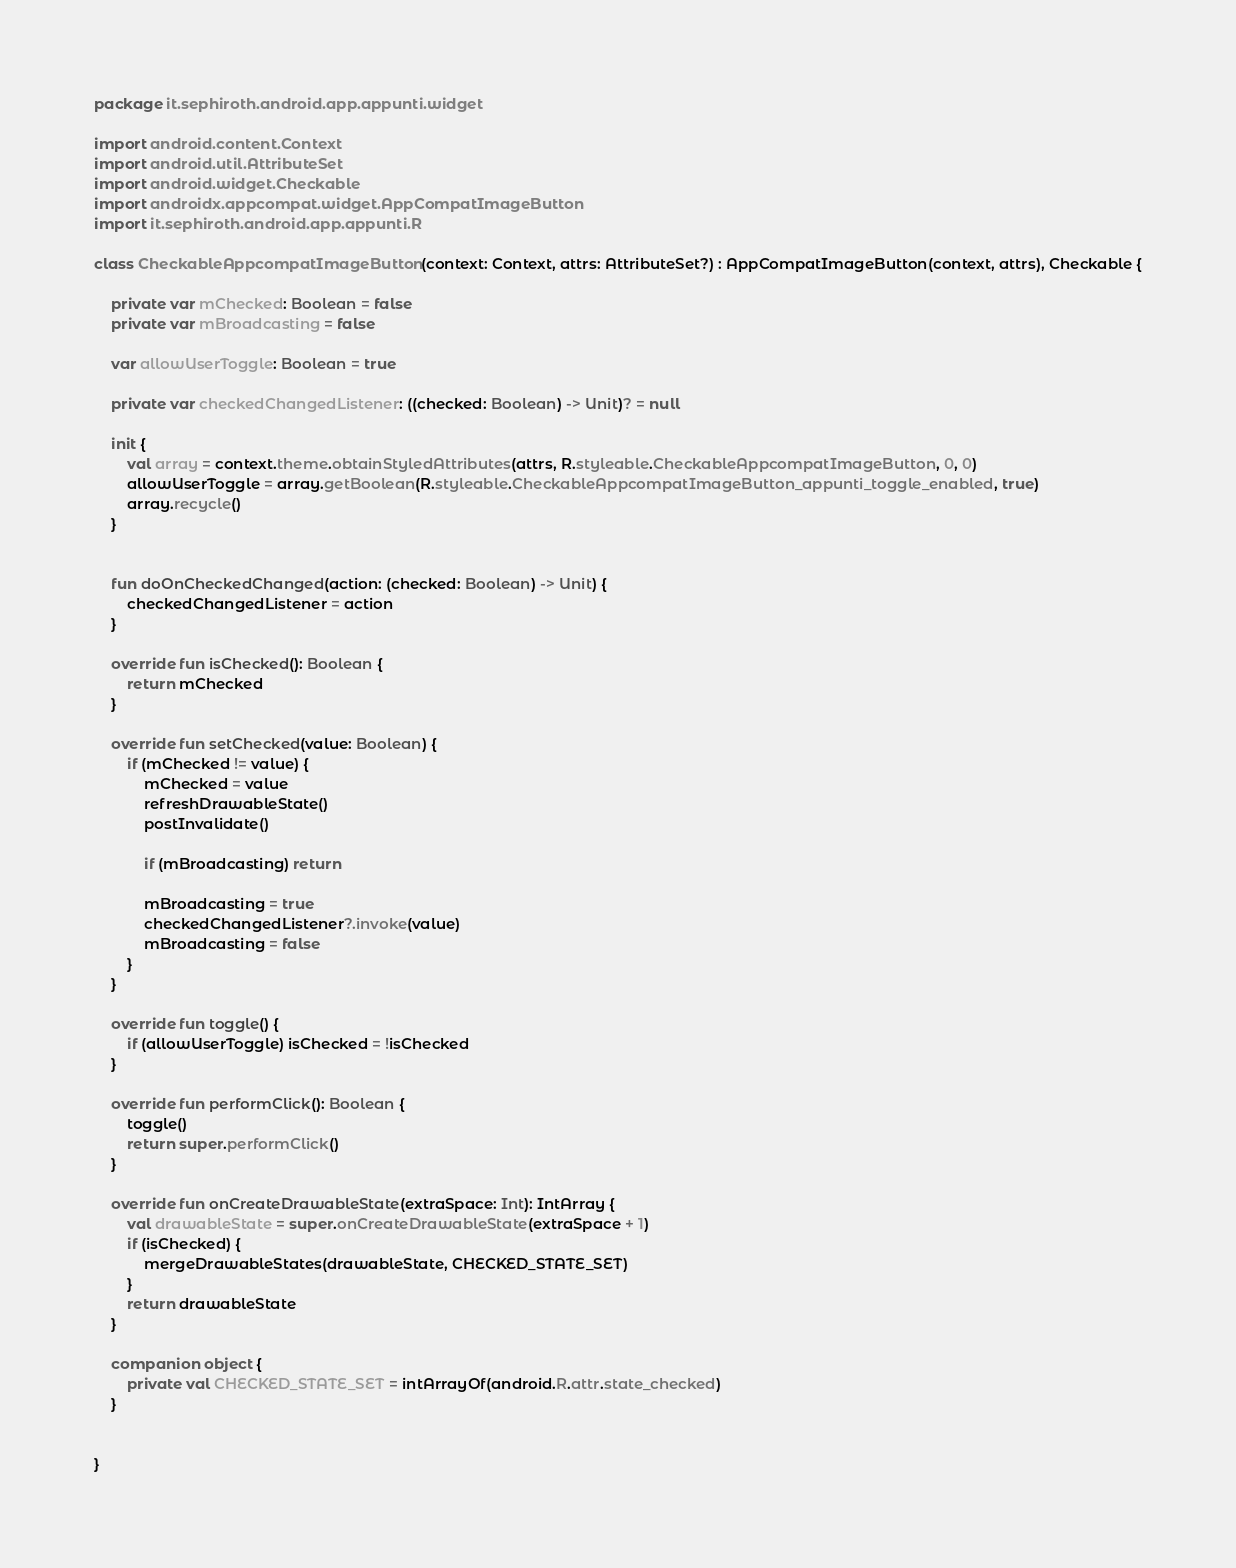<code> <loc_0><loc_0><loc_500><loc_500><_Kotlin_>package it.sephiroth.android.app.appunti.widget

import android.content.Context
import android.util.AttributeSet
import android.widget.Checkable
import androidx.appcompat.widget.AppCompatImageButton
import it.sephiroth.android.app.appunti.R

class CheckableAppcompatImageButton(context: Context, attrs: AttributeSet?) : AppCompatImageButton(context, attrs), Checkable {

    private var mChecked: Boolean = false
    private var mBroadcasting = false

    var allowUserToggle: Boolean = true

    private var checkedChangedListener: ((checked: Boolean) -> Unit)? = null

    init {
        val array = context.theme.obtainStyledAttributes(attrs, R.styleable.CheckableAppcompatImageButton, 0, 0)
        allowUserToggle = array.getBoolean(R.styleable.CheckableAppcompatImageButton_appunti_toggle_enabled, true)
        array.recycle()
    }


    fun doOnCheckedChanged(action: (checked: Boolean) -> Unit) {
        checkedChangedListener = action
    }

    override fun isChecked(): Boolean {
        return mChecked
    }

    override fun setChecked(value: Boolean) {
        if (mChecked != value) {
            mChecked = value
            refreshDrawableState()
            postInvalidate()

            if (mBroadcasting) return

            mBroadcasting = true
            checkedChangedListener?.invoke(value)
            mBroadcasting = false
        }
    }

    override fun toggle() {
        if (allowUserToggle) isChecked = !isChecked
    }

    override fun performClick(): Boolean {
        toggle()
        return super.performClick()
    }

    override fun onCreateDrawableState(extraSpace: Int): IntArray {
        val drawableState = super.onCreateDrawableState(extraSpace + 1)
        if (isChecked) {
            mergeDrawableStates(drawableState, CHECKED_STATE_SET)
        }
        return drawableState
    }

    companion object {
        private val CHECKED_STATE_SET = intArrayOf(android.R.attr.state_checked)
    }


}</code> 